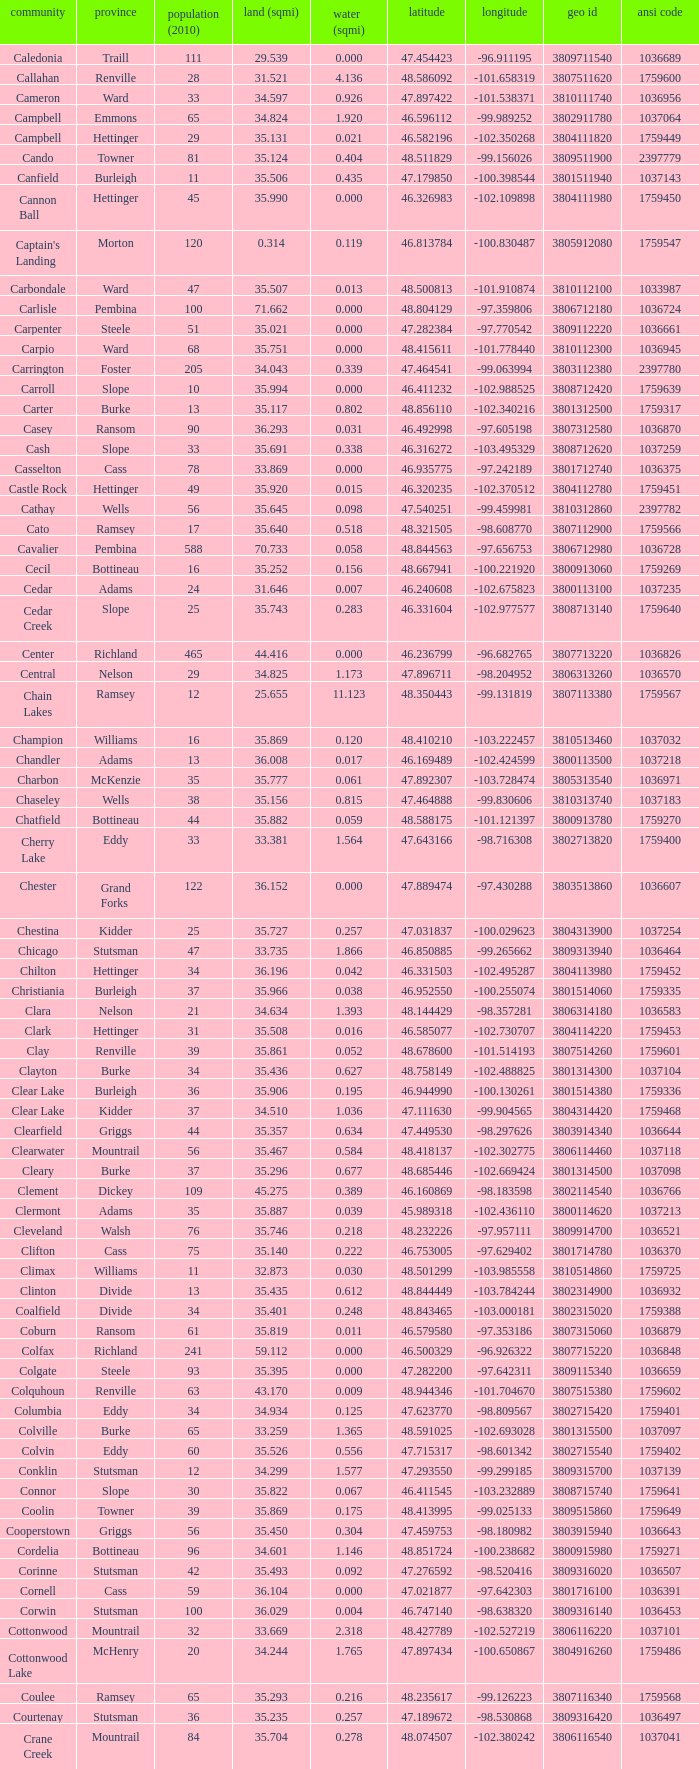Parse the table in full. {'header': ['community', 'province', 'population (2010)', 'land (sqmi)', 'water (sqmi)', 'latitude', 'longitude', 'geo id', 'ansi code'], 'rows': [['Caledonia', 'Traill', '111', '29.539', '0.000', '47.454423', '-96.911195', '3809711540', '1036689'], ['Callahan', 'Renville', '28', '31.521', '4.136', '48.586092', '-101.658319', '3807511620', '1759600'], ['Cameron', 'Ward', '33', '34.597', '0.926', '47.897422', '-101.538371', '3810111740', '1036956'], ['Campbell', 'Emmons', '65', '34.824', '1.920', '46.596112', '-99.989252', '3802911780', '1037064'], ['Campbell', 'Hettinger', '29', '35.131', '0.021', '46.582196', '-102.350268', '3804111820', '1759449'], ['Cando', 'Towner', '81', '35.124', '0.404', '48.511829', '-99.156026', '3809511900', '2397779'], ['Canfield', 'Burleigh', '11', '35.506', '0.435', '47.179850', '-100.398544', '3801511940', '1037143'], ['Cannon Ball', 'Hettinger', '45', '35.990', '0.000', '46.326983', '-102.109898', '3804111980', '1759450'], ["Captain's Landing", 'Morton', '120', '0.314', '0.119', '46.813784', '-100.830487', '3805912080', '1759547'], ['Carbondale', 'Ward', '47', '35.507', '0.013', '48.500813', '-101.910874', '3810112100', '1033987'], ['Carlisle', 'Pembina', '100', '71.662', '0.000', '48.804129', '-97.359806', '3806712180', '1036724'], ['Carpenter', 'Steele', '51', '35.021', '0.000', '47.282384', '-97.770542', '3809112220', '1036661'], ['Carpio', 'Ward', '68', '35.751', '0.000', '48.415611', '-101.778440', '3810112300', '1036945'], ['Carrington', 'Foster', '205', '34.043', '0.339', '47.464541', '-99.063994', '3803112380', '2397780'], ['Carroll', 'Slope', '10', '35.994', '0.000', '46.411232', '-102.988525', '3808712420', '1759639'], ['Carter', 'Burke', '13', '35.117', '0.802', '48.856110', '-102.340216', '3801312500', '1759317'], ['Casey', 'Ransom', '90', '36.293', '0.031', '46.492998', '-97.605198', '3807312580', '1036870'], ['Cash', 'Slope', '33', '35.691', '0.338', '46.316272', '-103.495329', '3808712620', '1037259'], ['Casselton', 'Cass', '78', '33.869', '0.000', '46.935775', '-97.242189', '3801712740', '1036375'], ['Castle Rock', 'Hettinger', '49', '35.920', '0.015', '46.320235', '-102.370512', '3804112780', '1759451'], ['Cathay', 'Wells', '56', '35.645', '0.098', '47.540251', '-99.459981', '3810312860', '2397782'], ['Cato', 'Ramsey', '17', '35.640', '0.518', '48.321505', '-98.608770', '3807112900', '1759566'], ['Cavalier', 'Pembina', '588', '70.733', '0.058', '48.844563', '-97.656753', '3806712980', '1036728'], ['Cecil', 'Bottineau', '16', '35.252', '0.156', '48.667941', '-100.221920', '3800913060', '1759269'], ['Cedar', 'Adams', '24', '31.646', '0.007', '46.240608', '-102.675823', '3800113100', '1037235'], ['Cedar Creek', 'Slope', '25', '35.743', '0.283', '46.331604', '-102.977577', '3808713140', '1759640'], ['Center', 'Richland', '465', '44.416', '0.000', '46.236799', '-96.682765', '3807713220', '1036826'], ['Central', 'Nelson', '29', '34.825', '1.173', '47.896711', '-98.204952', '3806313260', '1036570'], ['Chain Lakes', 'Ramsey', '12', '25.655', '11.123', '48.350443', '-99.131819', '3807113380', '1759567'], ['Champion', 'Williams', '16', '35.869', '0.120', '48.410210', '-103.222457', '3810513460', '1037032'], ['Chandler', 'Adams', '13', '36.008', '0.017', '46.169489', '-102.424599', '3800113500', '1037218'], ['Charbon', 'McKenzie', '35', '35.777', '0.061', '47.892307', '-103.728474', '3805313540', '1036971'], ['Chaseley', 'Wells', '38', '35.156', '0.815', '47.464888', '-99.830606', '3810313740', '1037183'], ['Chatfield', 'Bottineau', '44', '35.882', '0.059', '48.588175', '-101.121397', '3800913780', '1759270'], ['Cherry Lake', 'Eddy', '33', '33.381', '1.564', '47.643166', '-98.716308', '3802713820', '1759400'], ['Chester', 'Grand Forks', '122', '36.152', '0.000', '47.889474', '-97.430288', '3803513860', '1036607'], ['Chestina', 'Kidder', '25', '35.727', '0.257', '47.031837', '-100.029623', '3804313900', '1037254'], ['Chicago', 'Stutsman', '47', '33.735', '1.866', '46.850885', '-99.265662', '3809313940', '1036464'], ['Chilton', 'Hettinger', '34', '36.196', '0.042', '46.331503', '-102.495287', '3804113980', '1759452'], ['Christiania', 'Burleigh', '37', '35.966', '0.038', '46.952550', '-100.255074', '3801514060', '1759335'], ['Clara', 'Nelson', '21', '34.634', '1.393', '48.144429', '-98.357281', '3806314180', '1036583'], ['Clark', 'Hettinger', '31', '35.508', '0.016', '46.585077', '-102.730707', '3804114220', '1759453'], ['Clay', 'Renville', '39', '35.861', '0.052', '48.678600', '-101.514193', '3807514260', '1759601'], ['Clayton', 'Burke', '34', '35.436', '0.627', '48.758149', '-102.488825', '3801314300', '1037104'], ['Clear Lake', 'Burleigh', '36', '35.906', '0.195', '46.944990', '-100.130261', '3801514380', '1759336'], ['Clear Lake', 'Kidder', '37', '34.510', '1.036', '47.111630', '-99.904565', '3804314420', '1759468'], ['Clearfield', 'Griggs', '44', '35.357', '0.634', '47.449530', '-98.297626', '3803914340', '1036644'], ['Clearwater', 'Mountrail', '56', '35.467', '0.584', '48.418137', '-102.302775', '3806114460', '1037118'], ['Cleary', 'Burke', '37', '35.296', '0.677', '48.685446', '-102.669424', '3801314500', '1037098'], ['Clement', 'Dickey', '109', '45.275', '0.389', '46.160869', '-98.183598', '3802114540', '1036766'], ['Clermont', 'Adams', '35', '35.887', '0.039', '45.989318', '-102.436110', '3800114620', '1037213'], ['Cleveland', 'Walsh', '76', '35.746', '0.218', '48.232226', '-97.957111', '3809914700', '1036521'], ['Clifton', 'Cass', '75', '35.140', '0.222', '46.753005', '-97.629402', '3801714780', '1036370'], ['Climax', 'Williams', '11', '32.873', '0.030', '48.501299', '-103.985558', '3810514860', '1759725'], ['Clinton', 'Divide', '13', '35.435', '0.612', '48.844449', '-103.784244', '3802314900', '1036932'], ['Coalfield', 'Divide', '34', '35.401', '0.248', '48.843465', '-103.000181', '3802315020', '1759388'], ['Coburn', 'Ransom', '61', '35.819', '0.011', '46.579580', '-97.353186', '3807315060', '1036879'], ['Colfax', 'Richland', '241', '59.112', '0.000', '46.500329', '-96.926322', '3807715220', '1036848'], ['Colgate', 'Steele', '93', '35.395', '0.000', '47.282200', '-97.642311', '3809115340', '1036659'], ['Colquhoun', 'Renville', '63', '43.170', '0.009', '48.944346', '-101.704670', '3807515380', '1759602'], ['Columbia', 'Eddy', '34', '34.934', '0.125', '47.623770', '-98.809567', '3802715420', '1759401'], ['Colville', 'Burke', '65', '33.259', '1.365', '48.591025', '-102.693028', '3801315500', '1037097'], ['Colvin', 'Eddy', '60', '35.526', '0.556', '47.715317', '-98.601342', '3802715540', '1759402'], ['Conklin', 'Stutsman', '12', '34.299', '1.577', '47.293550', '-99.299185', '3809315700', '1037139'], ['Connor', 'Slope', '30', '35.822', '0.067', '46.411545', '-103.232889', '3808715740', '1759641'], ['Coolin', 'Towner', '39', '35.869', '0.175', '48.413995', '-99.025133', '3809515860', '1759649'], ['Cooperstown', 'Griggs', '56', '35.450', '0.304', '47.459753', '-98.180982', '3803915940', '1036643'], ['Cordelia', 'Bottineau', '96', '34.601', '1.146', '48.851724', '-100.238682', '3800915980', '1759271'], ['Corinne', 'Stutsman', '42', '35.493', '0.092', '47.276592', '-98.520416', '3809316020', '1036507'], ['Cornell', 'Cass', '59', '36.104', '0.000', '47.021877', '-97.642303', '3801716100', '1036391'], ['Corwin', 'Stutsman', '100', '36.029', '0.004', '46.747140', '-98.638320', '3809316140', '1036453'], ['Cottonwood', 'Mountrail', '32', '33.669', '2.318', '48.427789', '-102.527219', '3806116220', '1037101'], ['Cottonwood Lake', 'McHenry', '20', '34.244', '1.765', '47.897434', '-100.650867', '3804916260', '1759486'], ['Coulee', 'Ramsey', '65', '35.293', '0.216', '48.235617', '-99.126223', '3807116340', '1759568'], ['Courtenay', 'Stutsman', '36', '35.235', '0.257', '47.189672', '-98.530868', '3809316420', '1036497'], ['Crane Creek', 'Mountrail', '84', '35.704', '0.278', '48.074507', '-102.380242', '3806116540', '1037041'], ['Crawford', 'Slope', '31', '35.892', '0.051', '46.320329', '-103.729934', '3808716620', '1037166'], ['Creel', 'Ramsey', '1305', '14.578', '15.621', '48.075823', '-98.857272', '3807116660', '1759569'], ['Cremerville', 'McLean', '27', '35.739', '0.054', '47.811011', '-102.054883', '3805516700', '1759530'], ['Crocus', 'Towner', '44', '35.047', '0.940', '48.667289', '-99.155787', '3809516820', '1759650'], ['Crofte', 'Burleigh', '199', '36.163', '0.000', '47.026425', '-100.685988', '3801516860', '1037131'], ['Cromwell', 'Burleigh', '35', '36.208', '0.000', '47.026008', '-100.558805', '3801516900', '1037133'], ['Crowfoot', 'Mountrail', '18', '34.701', '1.283', '48.495946', '-102.180433', '3806116980', '1037050'], ['Crown Hill', 'Kidder', '7', '30.799', '1.468', '46.770977', '-100.025924', '3804317020', '1759469'], ['Crystal', 'Pembina', '50', '35.499', '0.000', '48.586423', '-97.732145', '3806717100', '1036718'], ['Crystal Lake', 'Wells', '32', '35.522', '0.424', '47.541346', '-99.974737', '3810317140', '1037152'], ['Crystal Springs', 'Kidder', '32', '35.415', '0.636', '46.848792', '-99.529639', '3804317220', '1759470'], ['Cuba', 'Barnes', '76', '35.709', '0.032', '46.851144', '-97.860271', '3800317300', '1036409'], ['Cusator', 'Stutsman', '26', '34.878', '0.693', '46.746853', '-98.997611', '3809317460', '1036459'], ['Cut Bank', 'Bottineau', '37', '35.898', '0.033', '48.763937', '-101.430571', '3800917540', '1759272']]} 770977? Kidder. 